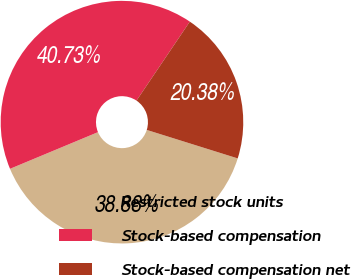<chart> <loc_0><loc_0><loc_500><loc_500><pie_chart><fcel>Restricted stock units<fcel>Stock-based compensation<fcel>Stock-based compensation net<nl><fcel>38.88%<fcel>40.73%<fcel>20.38%<nl></chart> 